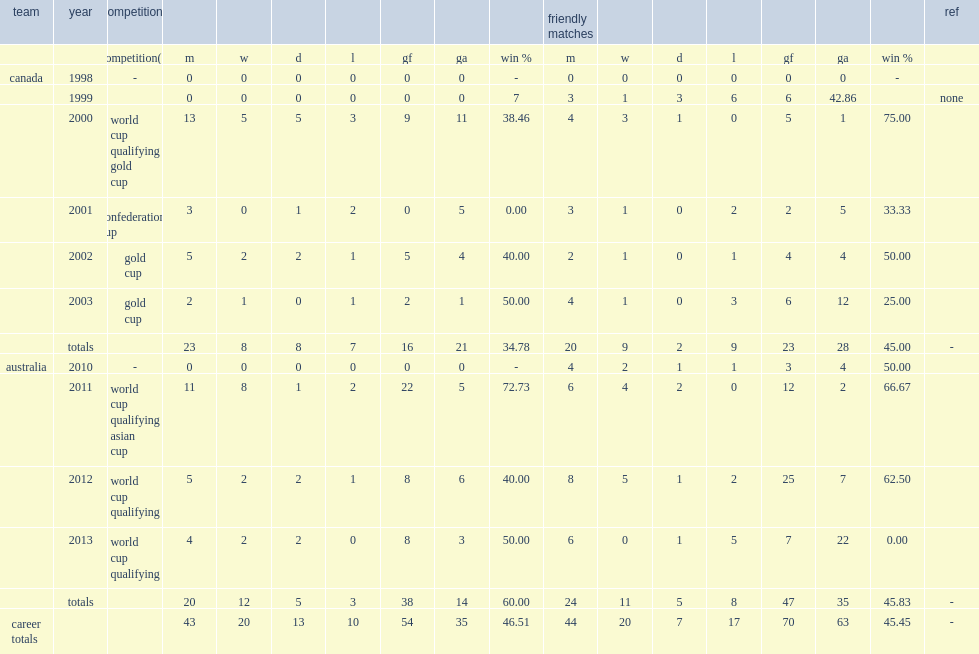In 2001, which competition did canada participate in? Confederations cup. 